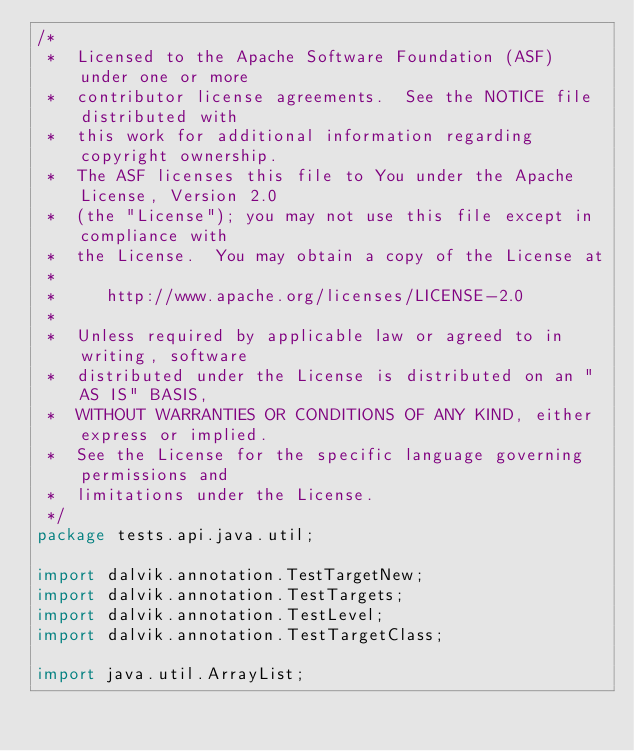Convert code to text. <code><loc_0><loc_0><loc_500><loc_500><_Java_>/*
 *  Licensed to the Apache Software Foundation (ASF) under one or more
 *  contributor license agreements.  See the NOTICE file distributed with
 *  this work for additional information regarding copyright ownership.
 *  The ASF licenses this file to You under the Apache License, Version 2.0
 *  (the "License"); you may not use this file except in compliance with
 *  the License.  You may obtain a copy of the License at
 *
 *     http://www.apache.org/licenses/LICENSE-2.0
 *
 *  Unless required by applicable law or agreed to in writing, software
 *  distributed under the License is distributed on an "AS IS" BASIS,
 *  WITHOUT WARRANTIES OR CONDITIONS OF ANY KIND, either express or implied.
 *  See the License for the specific language governing permissions and
 *  limitations under the License.
 */
package tests.api.java.util;

import dalvik.annotation.TestTargetNew;
import dalvik.annotation.TestTargets;
import dalvik.annotation.TestLevel;
import dalvik.annotation.TestTargetClass;

import java.util.ArrayList;</code> 